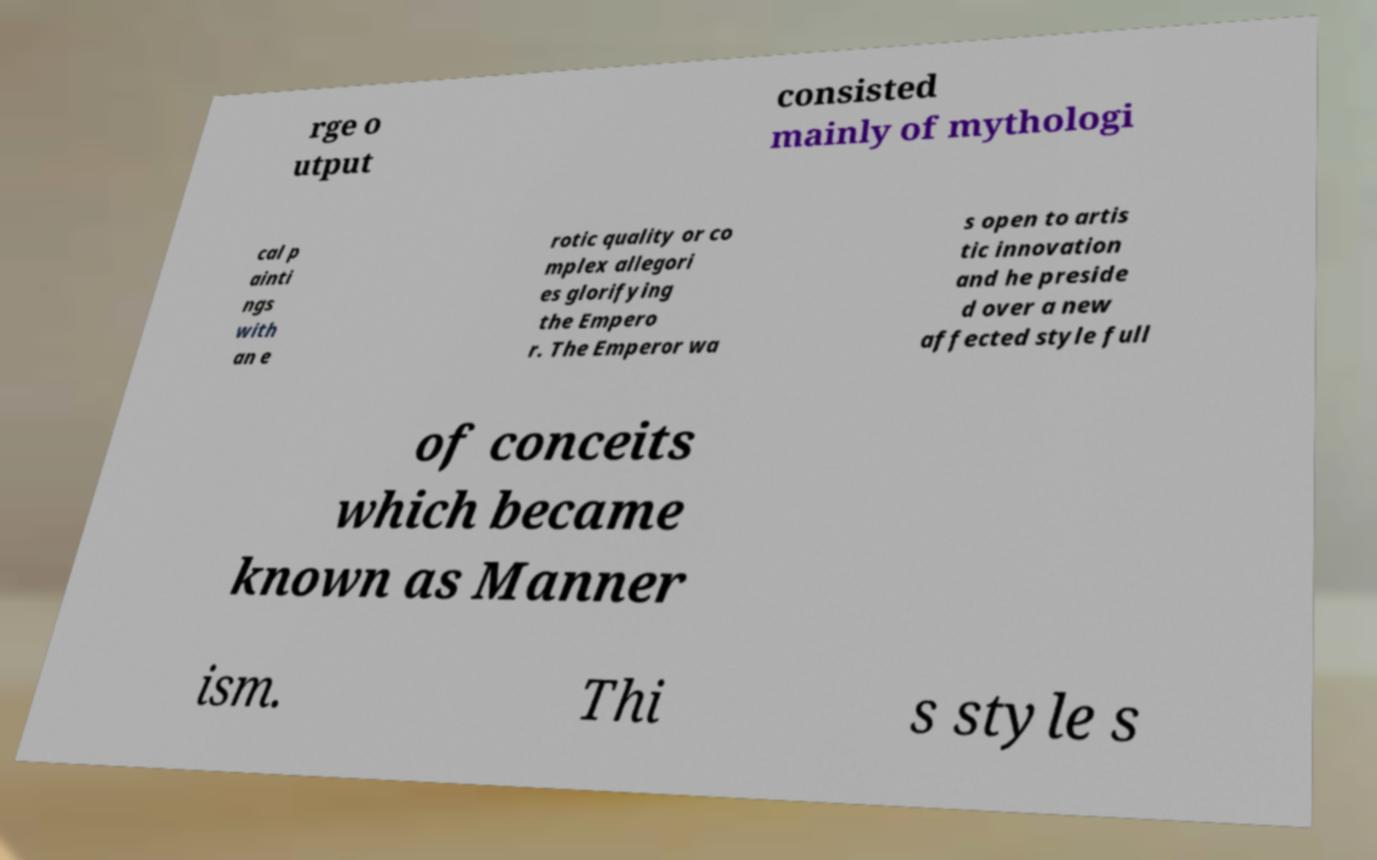Could you assist in decoding the text presented in this image and type it out clearly? rge o utput consisted mainly of mythologi cal p ainti ngs with an e rotic quality or co mplex allegori es glorifying the Empero r. The Emperor wa s open to artis tic innovation and he preside d over a new affected style full of conceits which became known as Manner ism. Thi s style s 